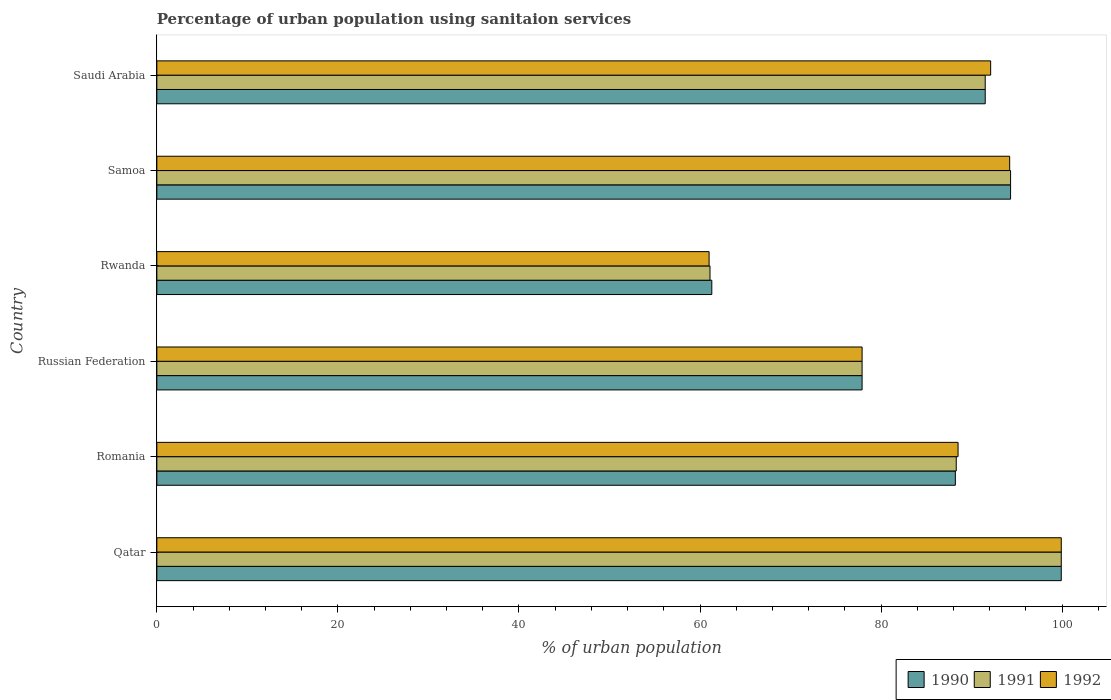How many groups of bars are there?
Your answer should be very brief. 6. What is the label of the 4th group of bars from the top?
Keep it short and to the point. Russian Federation. In how many cases, is the number of bars for a given country not equal to the number of legend labels?
Your answer should be compact. 0. What is the percentage of urban population using sanitaion services in 1991 in Samoa?
Provide a succinct answer. 94.3. Across all countries, what is the maximum percentage of urban population using sanitaion services in 1990?
Your answer should be very brief. 99.9. Across all countries, what is the minimum percentage of urban population using sanitaion services in 1990?
Your response must be concise. 61.3. In which country was the percentage of urban population using sanitaion services in 1990 maximum?
Give a very brief answer. Qatar. In which country was the percentage of urban population using sanitaion services in 1992 minimum?
Your answer should be very brief. Rwanda. What is the total percentage of urban population using sanitaion services in 1992 in the graph?
Provide a succinct answer. 513.6. What is the difference between the percentage of urban population using sanitaion services in 1990 in Romania and that in Samoa?
Keep it short and to the point. -6.1. What is the difference between the percentage of urban population using sanitaion services in 1992 in Rwanda and the percentage of urban population using sanitaion services in 1991 in Samoa?
Your answer should be compact. -33.3. What is the average percentage of urban population using sanitaion services in 1991 per country?
Offer a very short reply. 85.5. In how many countries, is the percentage of urban population using sanitaion services in 1991 greater than 16 %?
Keep it short and to the point. 6. What is the ratio of the percentage of urban population using sanitaion services in 1991 in Qatar to that in Saudi Arabia?
Provide a succinct answer. 1.09. Is the percentage of urban population using sanitaion services in 1990 in Qatar less than that in Rwanda?
Give a very brief answer. No. Is the difference between the percentage of urban population using sanitaion services in 1991 in Romania and Samoa greater than the difference between the percentage of urban population using sanitaion services in 1992 in Romania and Samoa?
Make the answer very short. No. What is the difference between the highest and the second highest percentage of urban population using sanitaion services in 1991?
Provide a succinct answer. 5.6. What is the difference between the highest and the lowest percentage of urban population using sanitaion services in 1992?
Keep it short and to the point. 38.9. In how many countries, is the percentage of urban population using sanitaion services in 1990 greater than the average percentage of urban population using sanitaion services in 1990 taken over all countries?
Provide a succinct answer. 4. Is the sum of the percentage of urban population using sanitaion services in 1990 in Qatar and Saudi Arabia greater than the maximum percentage of urban population using sanitaion services in 1992 across all countries?
Offer a terse response. Yes. What does the 1st bar from the top in Samoa represents?
Make the answer very short. 1992. What does the 2nd bar from the bottom in Rwanda represents?
Offer a terse response. 1991. Is it the case that in every country, the sum of the percentage of urban population using sanitaion services in 1991 and percentage of urban population using sanitaion services in 1990 is greater than the percentage of urban population using sanitaion services in 1992?
Your answer should be very brief. Yes. How many bars are there?
Make the answer very short. 18. Are all the bars in the graph horizontal?
Offer a very short reply. Yes. How many countries are there in the graph?
Ensure brevity in your answer.  6. What is the difference between two consecutive major ticks on the X-axis?
Your response must be concise. 20. Where does the legend appear in the graph?
Provide a short and direct response. Bottom right. How many legend labels are there?
Give a very brief answer. 3. What is the title of the graph?
Provide a succinct answer. Percentage of urban population using sanitaion services. Does "1985" appear as one of the legend labels in the graph?
Provide a succinct answer. No. What is the label or title of the X-axis?
Keep it short and to the point. % of urban population. What is the label or title of the Y-axis?
Offer a very short reply. Country. What is the % of urban population in 1990 in Qatar?
Your response must be concise. 99.9. What is the % of urban population of 1991 in Qatar?
Provide a succinct answer. 99.9. What is the % of urban population in 1992 in Qatar?
Offer a very short reply. 99.9. What is the % of urban population in 1990 in Romania?
Give a very brief answer. 88.2. What is the % of urban population of 1991 in Romania?
Provide a succinct answer. 88.3. What is the % of urban population in 1992 in Romania?
Make the answer very short. 88.5. What is the % of urban population in 1990 in Russian Federation?
Your answer should be very brief. 77.9. What is the % of urban population of 1991 in Russian Federation?
Ensure brevity in your answer.  77.9. What is the % of urban population of 1992 in Russian Federation?
Ensure brevity in your answer.  77.9. What is the % of urban population of 1990 in Rwanda?
Your response must be concise. 61.3. What is the % of urban population of 1991 in Rwanda?
Provide a succinct answer. 61.1. What is the % of urban population in 1992 in Rwanda?
Provide a short and direct response. 61. What is the % of urban population of 1990 in Samoa?
Your answer should be very brief. 94.3. What is the % of urban population of 1991 in Samoa?
Your answer should be compact. 94.3. What is the % of urban population in 1992 in Samoa?
Provide a short and direct response. 94.2. What is the % of urban population in 1990 in Saudi Arabia?
Make the answer very short. 91.5. What is the % of urban population of 1991 in Saudi Arabia?
Provide a short and direct response. 91.5. What is the % of urban population in 1992 in Saudi Arabia?
Your answer should be compact. 92.1. Across all countries, what is the maximum % of urban population in 1990?
Provide a succinct answer. 99.9. Across all countries, what is the maximum % of urban population in 1991?
Offer a very short reply. 99.9. Across all countries, what is the maximum % of urban population in 1992?
Offer a very short reply. 99.9. Across all countries, what is the minimum % of urban population of 1990?
Give a very brief answer. 61.3. Across all countries, what is the minimum % of urban population in 1991?
Give a very brief answer. 61.1. Across all countries, what is the minimum % of urban population of 1992?
Give a very brief answer. 61. What is the total % of urban population in 1990 in the graph?
Provide a short and direct response. 513.1. What is the total % of urban population of 1991 in the graph?
Offer a very short reply. 513. What is the total % of urban population in 1992 in the graph?
Make the answer very short. 513.6. What is the difference between the % of urban population in 1992 in Qatar and that in Romania?
Give a very brief answer. 11.4. What is the difference between the % of urban population of 1990 in Qatar and that in Russian Federation?
Offer a terse response. 22. What is the difference between the % of urban population of 1990 in Qatar and that in Rwanda?
Provide a succinct answer. 38.6. What is the difference between the % of urban population in 1991 in Qatar and that in Rwanda?
Provide a succinct answer. 38.8. What is the difference between the % of urban population of 1992 in Qatar and that in Rwanda?
Your answer should be compact. 38.9. What is the difference between the % of urban population in 1991 in Qatar and that in Samoa?
Provide a succinct answer. 5.6. What is the difference between the % of urban population of 1991 in Romania and that in Russian Federation?
Your answer should be very brief. 10.4. What is the difference between the % of urban population in 1990 in Romania and that in Rwanda?
Make the answer very short. 26.9. What is the difference between the % of urban population in 1991 in Romania and that in Rwanda?
Give a very brief answer. 27.2. What is the difference between the % of urban population in 1990 in Romania and that in Samoa?
Offer a very short reply. -6.1. What is the difference between the % of urban population of 1991 in Romania and that in Samoa?
Offer a terse response. -6. What is the difference between the % of urban population in 1990 in Russian Federation and that in Rwanda?
Offer a very short reply. 16.6. What is the difference between the % of urban population of 1991 in Russian Federation and that in Rwanda?
Your answer should be compact. 16.8. What is the difference between the % of urban population in 1990 in Russian Federation and that in Samoa?
Make the answer very short. -16.4. What is the difference between the % of urban population in 1991 in Russian Federation and that in Samoa?
Give a very brief answer. -16.4. What is the difference between the % of urban population of 1992 in Russian Federation and that in Samoa?
Provide a short and direct response. -16.3. What is the difference between the % of urban population of 1990 in Rwanda and that in Samoa?
Offer a very short reply. -33. What is the difference between the % of urban population of 1991 in Rwanda and that in Samoa?
Ensure brevity in your answer.  -33.2. What is the difference between the % of urban population of 1992 in Rwanda and that in Samoa?
Give a very brief answer. -33.2. What is the difference between the % of urban population of 1990 in Rwanda and that in Saudi Arabia?
Your answer should be very brief. -30.2. What is the difference between the % of urban population of 1991 in Rwanda and that in Saudi Arabia?
Offer a terse response. -30.4. What is the difference between the % of urban population in 1992 in Rwanda and that in Saudi Arabia?
Your response must be concise. -31.1. What is the difference between the % of urban population of 1990 in Samoa and that in Saudi Arabia?
Offer a very short reply. 2.8. What is the difference between the % of urban population in 1991 in Samoa and that in Saudi Arabia?
Offer a terse response. 2.8. What is the difference between the % of urban population in 1992 in Samoa and that in Saudi Arabia?
Your answer should be very brief. 2.1. What is the difference between the % of urban population in 1991 in Qatar and the % of urban population in 1992 in Romania?
Provide a succinct answer. 11.4. What is the difference between the % of urban population of 1990 in Qatar and the % of urban population of 1991 in Russian Federation?
Give a very brief answer. 22. What is the difference between the % of urban population in 1990 in Qatar and the % of urban population in 1992 in Russian Federation?
Offer a terse response. 22. What is the difference between the % of urban population in 1990 in Qatar and the % of urban population in 1991 in Rwanda?
Provide a succinct answer. 38.8. What is the difference between the % of urban population in 1990 in Qatar and the % of urban population in 1992 in Rwanda?
Your answer should be very brief. 38.9. What is the difference between the % of urban population in 1991 in Qatar and the % of urban population in 1992 in Rwanda?
Offer a terse response. 38.9. What is the difference between the % of urban population of 1990 in Romania and the % of urban population of 1992 in Russian Federation?
Give a very brief answer. 10.3. What is the difference between the % of urban population of 1991 in Romania and the % of urban population of 1992 in Russian Federation?
Your answer should be compact. 10.4. What is the difference between the % of urban population in 1990 in Romania and the % of urban population in 1991 in Rwanda?
Your answer should be compact. 27.1. What is the difference between the % of urban population in 1990 in Romania and the % of urban population in 1992 in Rwanda?
Offer a very short reply. 27.2. What is the difference between the % of urban population in 1991 in Romania and the % of urban population in 1992 in Rwanda?
Ensure brevity in your answer.  27.3. What is the difference between the % of urban population of 1990 in Romania and the % of urban population of 1991 in Samoa?
Make the answer very short. -6.1. What is the difference between the % of urban population in 1991 in Romania and the % of urban population in 1992 in Samoa?
Ensure brevity in your answer.  -5.9. What is the difference between the % of urban population in 1990 in Romania and the % of urban population in 1992 in Saudi Arabia?
Provide a succinct answer. -3.9. What is the difference between the % of urban population of 1991 in Romania and the % of urban population of 1992 in Saudi Arabia?
Offer a terse response. -3.8. What is the difference between the % of urban population in 1991 in Russian Federation and the % of urban population in 1992 in Rwanda?
Provide a short and direct response. 16.9. What is the difference between the % of urban population of 1990 in Russian Federation and the % of urban population of 1991 in Samoa?
Offer a very short reply. -16.4. What is the difference between the % of urban population of 1990 in Russian Federation and the % of urban population of 1992 in Samoa?
Keep it short and to the point. -16.3. What is the difference between the % of urban population of 1991 in Russian Federation and the % of urban population of 1992 in Samoa?
Provide a succinct answer. -16.3. What is the difference between the % of urban population of 1990 in Russian Federation and the % of urban population of 1992 in Saudi Arabia?
Ensure brevity in your answer.  -14.2. What is the difference between the % of urban population of 1991 in Russian Federation and the % of urban population of 1992 in Saudi Arabia?
Provide a succinct answer. -14.2. What is the difference between the % of urban population in 1990 in Rwanda and the % of urban population in 1991 in Samoa?
Ensure brevity in your answer.  -33. What is the difference between the % of urban population in 1990 in Rwanda and the % of urban population in 1992 in Samoa?
Offer a terse response. -32.9. What is the difference between the % of urban population of 1991 in Rwanda and the % of urban population of 1992 in Samoa?
Offer a very short reply. -33.1. What is the difference between the % of urban population in 1990 in Rwanda and the % of urban population in 1991 in Saudi Arabia?
Offer a terse response. -30.2. What is the difference between the % of urban population of 1990 in Rwanda and the % of urban population of 1992 in Saudi Arabia?
Make the answer very short. -30.8. What is the difference between the % of urban population of 1991 in Rwanda and the % of urban population of 1992 in Saudi Arabia?
Your response must be concise. -31. What is the average % of urban population of 1990 per country?
Your response must be concise. 85.52. What is the average % of urban population in 1991 per country?
Your answer should be compact. 85.5. What is the average % of urban population in 1992 per country?
Your answer should be compact. 85.6. What is the difference between the % of urban population in 1990 and % of urban population in 1991 in Romania?
Provide a succinct answer. -0.1. What is the difference between the % of urban population of 1990 and % of urban population of 1992 in Romania?
Your response must be concise. -0.3. What is the difference between the % of urban population of 1991 and % of urban population of 1992 in Romania?
Make the answer very short. -0.2. What is the difference between the % of urban population of 1991 and % of urban population of 1992 in Russian Federation?
Offer a terse response. 0. What is the difference between the % of urban population in 1991 and % of urban population in 1992 in Samoa?
Provide a succinct answer. 0.1. What is the ratio of the % of urban population of 1990 in Qatar to that in Romania?
Keep it short and to the point. 1.13. What is the ratio of the % of urban population of 1991 in Qatar to that in Romania?
Offer a very short reply. 1.13. What is the ratio of the % of urban population of 1992 in Qatar to that in Romania?
Offer a very short reply. 1.13. What is the ratio of the % of urban population of 1990 in Qatar to that in Russian Federation?
Give a very brief answer. 1.28. What is the ratio of the % of urban population in 1991 in Qatar to that in Russian Federation?
Offer a very short reply. 1.28. What is the ratio of the % of urban population in 1992 in Qatar to that in Russian Federation?
Ensure brevity in your answer.  1.28. What is the ratio of the % of urban population in 1990 in Qatar to that in Rwanda?
Ensure brevity in your answer.  1.63. What is the ratio of the % of urban population of 1991 in Qatar to that in Rwanda?
Keep it short and to the point. 1.64. What is the ratio of the % of urban population in 1992 in Qatar to that in Rwanda?
Give a very brief answer. 1.64. What is the ratio of the % of urban population of 1990 in Qatar to that in Samoa?
Offer a terse response. 1.06. What is the ratio of the % of urban population of 1991 in Qatar to that in Samoa?
Provide a succinct answer. 1.06. What is the ratio of the % of urban population in 1992 in Qatar to that in Samoa?
Make the answer very short. 1.06. What is the ratio of the % of urban population of 1990 in Qatar to that in Saudi Arabia?
Offer a terse response. 1.09. What is the ratio of the % of urban population in 1991 in Qatar to that in Saudi Arabia?
Offer a terse response. 1.09. What is the ratio of the % of urban population in 1992 in Qatar to that in Saudi Arabia?
Give a very brief answer. 1.08. What is the ratio of the % of urban population of 1990 in Romania to that in Russian Federation?
Keep it short and to the point. 1.13. What is the ratio of the % of urban population in 1991 in Romania to that in Russian Federation?
Ensure brevity in your answer.  1.13. What is the ratio of the % of urban population in 1992 in Romania to that in Russian Federation?
Your answer should be very brief. 1.14. What is the ratio of the % of urban population in 1990 in Romania to that in Rwanda?
Keep it short and to the point. 1.44. What is the ratio of the % of urban population in 1991 in Romania to that in Rwanda?
Your answer should be very brief. 1.45. What is the ratio of the % of urban population of 1992 in Romania to that in Rwanda?
Offer a very short reply. 1.45. What is the ratio of the % of urban population of 1990 in Romania to that in Samoa?
Offer a very short reply. 0.94. What is the ratio of the % of urban population of 1991 in Romania to that in Samoa?
Give a very brief answer. 0.94. What is the ratio of the % of urban population in 1992 in Romania to that in Samoa?
Ensure brevity in your answer.  0.94. What is the ratio of the % of urban population in 1990 in Romania to that in Saudi Arabia?
Ensure brevity in your answer.  0.96. What is the ratio of the % of urban population of 1992 in Romania to that in Saudi Arabia?
Provide a short and direct response. 0.96. What is the ratio of the % of urban population in 1990 in Russian Federation to that in Rwanda?
Give a very brief answer. 1.27. What is the ratio of the % of urban population of 1991 in Russian Federation to that in Rwanda?
Your answer should be very brief. 1.27. What is the ratio of the % of urban population of 1992 in Russian Federation to that in Rwanda?
Offer a terse response. 1.28. What is the ratio of the % of urban population in 1990 in Russian Federation to that in Samoa?
Your answer should be compact. 0.83. What is the ratio of the % of urban population in 1991 in Russian Federation to that in Samoa?
Provide a short and direct response. 0.83. What is the ratio of the % of urban population of 1992 in Russian Federation to that in Samoa?
Ensure brevity in your answer.  0.83. What is the ratio of the % of urban population in 1990 in Russian Federation to that in Saudi Arabia?
Offer a terse response. 0.85. What is the ratio of the % of urban population in 1991 in Russian Federation to that in Saudi Arabia?
Make the answer very short. 0.85. What is the ratio of the % of urban population in 1992 in Russian Federation to that in Saudi Arabia?
Ensure brevity in your answer.  0.85. What is the ratio of the % of urban population of 1990 in Rwanda to that in Samoa?
Offer a terse response. 0.65. What is the ratio of the % of urban population of 1991 in Rwanda to that in Samoa?
Provide a succinct answer. 0.65. What is the ratio of the % of urban population in 1992 in Rwanda to that in Samoa?
Keep it short and to the point. 0.65. What is the ratio of the % of urban population in 1990 in Rwanda to that in Saudi Arabia?
Offer a terse response. 0.67. What is the ratio of the % of urban population in 1991 in Rwanda to that in Saudi Arabia?
Give a very brief answer. 0.67. What is the ratio of the % of urban population in 1992 in Rwanda to that in Saudi Arabia?
Give a very brief answer. 0.66. What is the ratio of the % of urban population in 1990 in Samoa to that in Saudi Arabia?
Your answer should be compact. 1.03. What is the ratio of the % of urban population of 1991 in Samoa to that in Saudi Arabia?
Keep it short and to the point. 1.03. What is the ratio of the % of urban population of 1992 in Samoa to that in Saudi Arabia?
Your response must be concise. 1.02. What is the difference between the highest and the second highest % of urban population in 1992?
Offer a very short reply. 5.7. What is the difference between the highest and the lowest % of urban population in 1990?
Provide a short and direct response. 38.6. What is the difference between the highest and the lowest % of urban population in 1991?
Your answer should be compact. 38.8. What is the difference between the highest and the lowest % of urban population in 1992?
Provide a succinct answer. 38.9. 